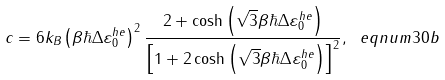<formula> <loc_0><loc_0><loc_500><loc_500>c = 6 k _ { B } \left ( \beta \hbar { \Delta } \varepsilon _ { 0 } ^ { h e } \right ) ^ { 2 } \frac { 2 + \cosh \left ( \sqrt { 3 } \beta \hbar { \Delta } \varepsilon _ { 0 } ^ { h e } \right ) } { \left [ 1 + 2 \cosh \left ( \sqrt { 3 } \beta \hbar { \Delta } \varepsilon _ { 0 } ^ { h e } \right ) \right ] ^ { 2 } } , \ e q n u m { 3 0 b }</formula> 